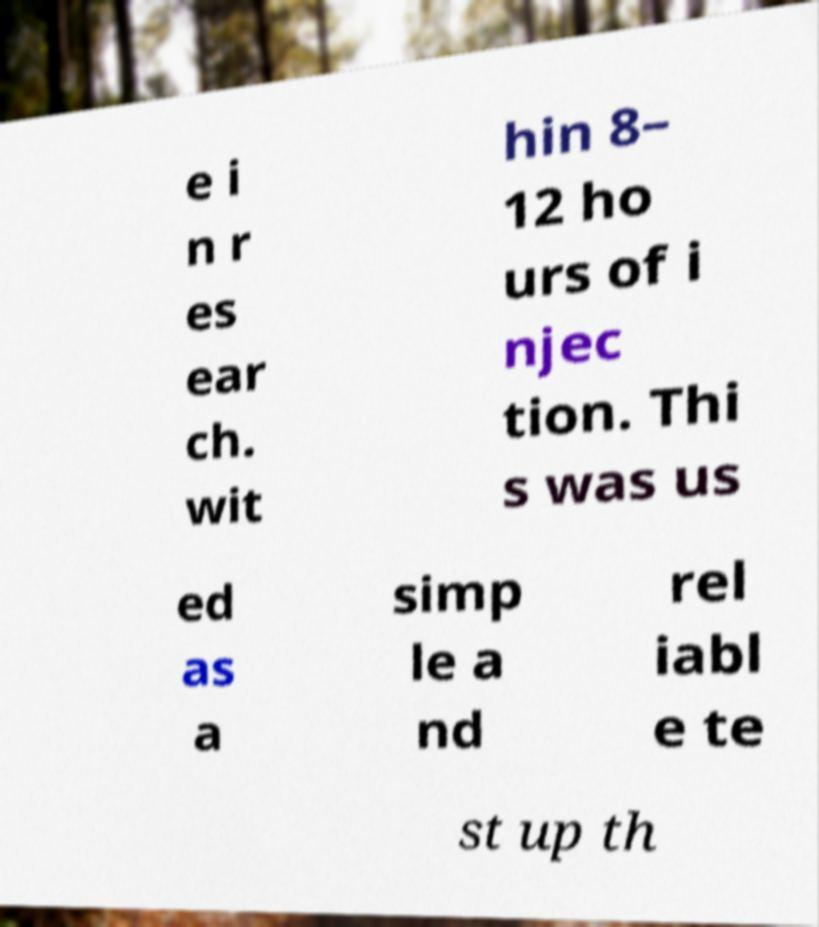What messages or text are displayed in this image? I need them in a readable, typed format. e i n r es ear ch. wit hin 8– 12 ho urs of i njec tion. Thi s was us ed as a simp le a nd rel iabl e te st up th 